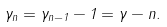Convert formula to latex. <formula><loc_0><loc_0><loc_500><loc_500>\gamma _ { n } = \gamma _ { n - 1 } - 1 = \gamma - n .</formula> 